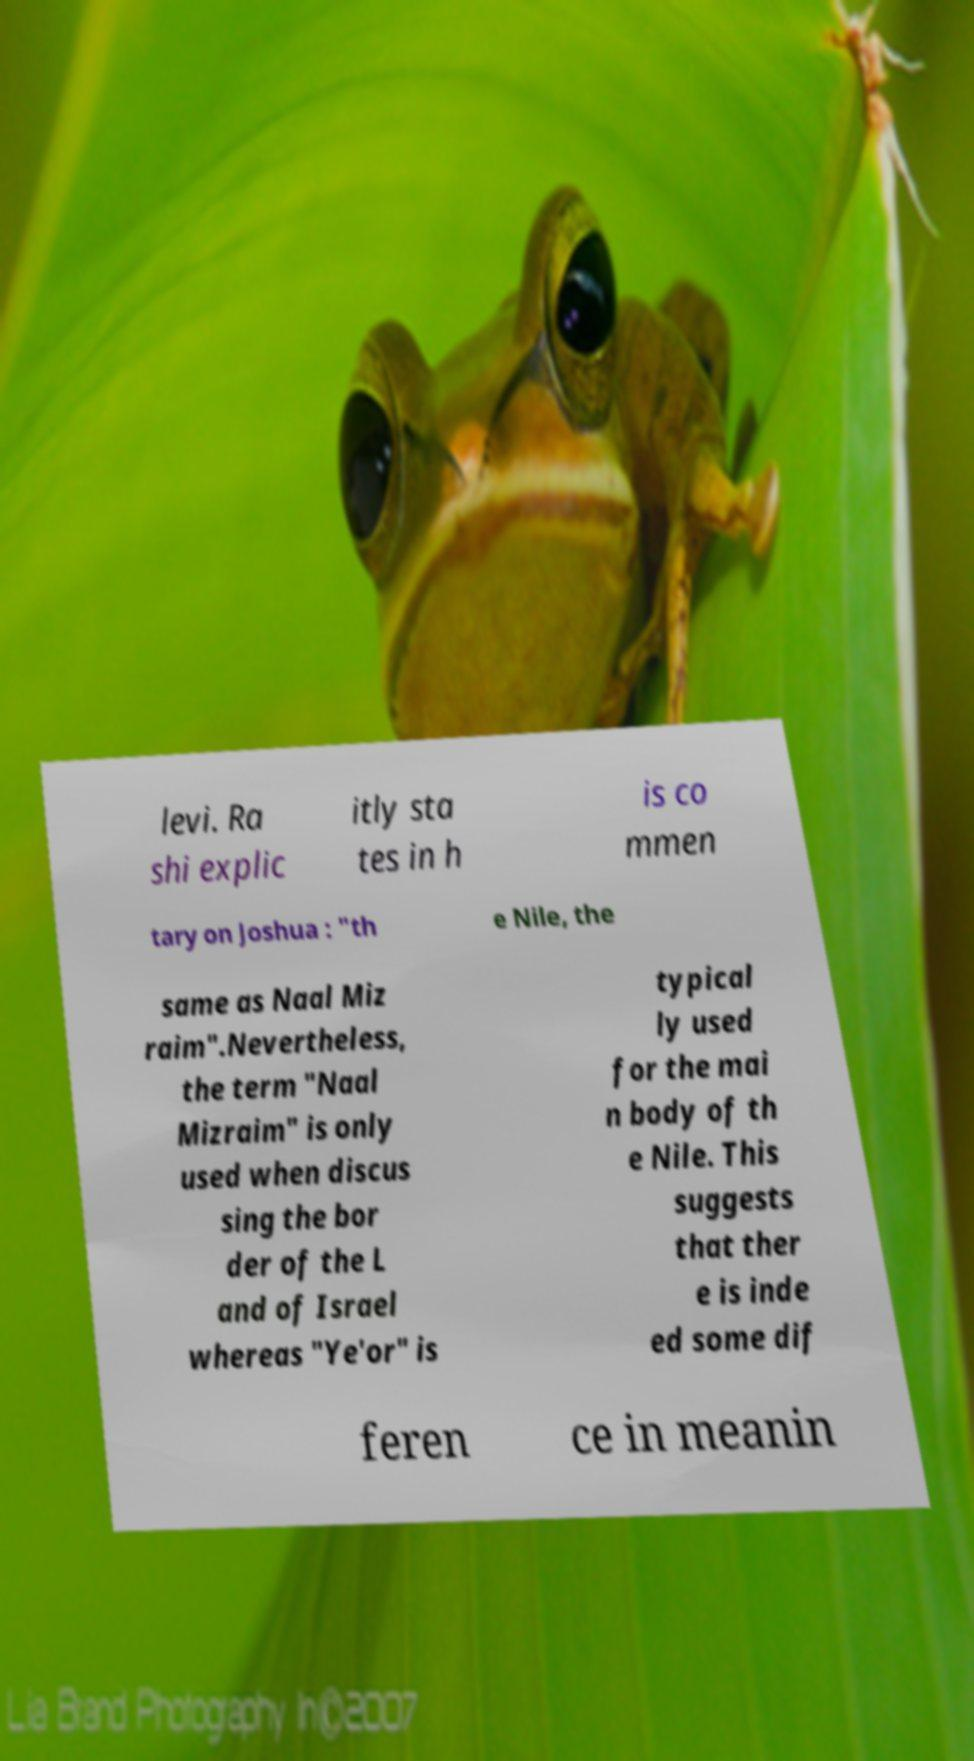Could you assist in decoding the text presented in this image and type it out clearly? levi. Ra shi explic itly sta tes in h is co mmen tary on Joshua : "th e Nile, the same as Naal Miz raim".Nevertheless, the term "Naal Mizraim" is only used when discus sing the bor der of the L and of Israel whereas "Ye'or" is typical ly used for the mai n body of th e Nile. This suggests that ther e is inde ed some dif feren ce in meanin 